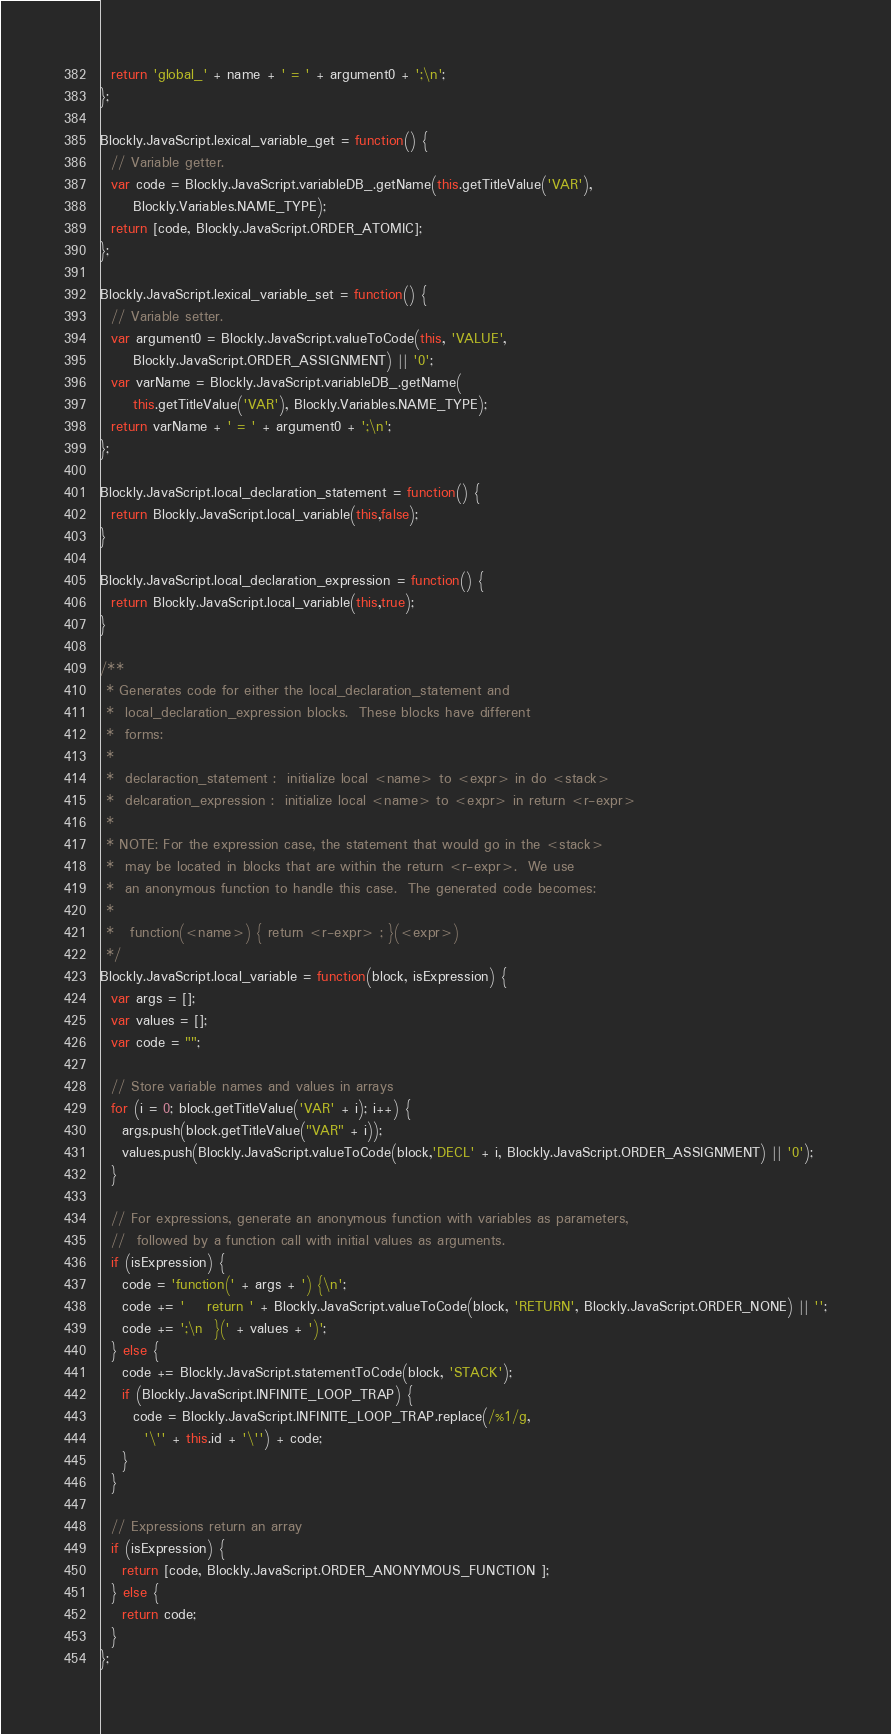<code> <loc_0><loc_0><loc_500><loc_500><_JavaScript_>  return 'global_' + name + ' = ' + argument0 + ';\n';
};

Blockly.JavaScript.lexical_variable_get = function() {
  // Variable getter.
  var code = Blockly.JavaScript.variableDB_.getName(this.getTitleValue('VAR'),
      Blockly.Variables.NAME_TYPE);
  return [code, Blockly.JavaScript.ORDER_ATOMIC];
};

Blockly.JavaScript.lexical_variable_set = function() {
  // Variable setter.
  var argument0 = Blockly.JavaScript.valueToCode(this, 'VALUE',
      Blockly.JavaScript.ORDER_ASSIGNMENT) || '0';
  var varName = Blockly.JavaScript.variableDB_.getName(
      this.getTitleValue('VAR'), Blockly.Variables.NAME_TYPE);
  return varName + ' = ' + argument0 + ';\n';
};

Blockly.JavaScript.local_declaration_statement = function() {
  return Blockly.JavaScript.local_variable(this,false);
}

Blockly.JavaScript.local_declaration_expression = function() {
  return Blockly.JavaScript.local_variable(this,true);
}

/**
 * Generates code for either the local_declaration_statement and
 *  local_declaration_expression blocks.  These blocks have different
 *  forms:
 *
 *  declaraction_statement :  initialize local <name> to <expr> in do <stack>
 *  delcaration_expression :  initialize local <name> to <expr> in return <r-expr>
 *
 * NOTE: For the expression case, the statement that would go in the <stack>
 *  may be located in blocks that are within the return <r-expr>.  We use
 *  an anonymous function to handle this case.  The generated code becomes:
 *
 *   function(<name>) { return <r-expr> ; }(<expr>)
 */
Blockly.JavaScript.local_variable = function(block, isExpression) {
  var args = [];
  var values = [];
  var code = "";

  // Store variable names and values in arrays
  for (i = 0; block.getTitleValue('VAR' + i); i++) {
    args.push(block.getTitleValue("VAR" + i));
    values.push(Blockly.JavaScript.valueToCode(block,'DECL' + i, Blockly.JavaScript.ORDER_ASSIGNMENT) || '0');
  }

  // For expressions, generate an anonymous function with variables as parameters,
  //  followed by a function call with initial values as arguments.
  if (isExpression) {
    code = 'function(' + args + ') {\n';
    code += '    return ' + Blockly.JavaScript.valueToCode(block, 'RETURN', Blockly.JavaScript.ORDER_NONE) || '';
    code += ';\n  }(' + values + ')';
  } else {
    code += Blockly.JavaScript.statementToCode(block, 'STACK');
    if (Blockly.JavaScript.INFINITE_LOOP_TRAP) {
      code = Blockly.JavaScript.INFINITE_LOOP_TRAP.replace(/%1/g,
        '\'' + this.id + '\'') + code;
    }
  }
  
  // Expressions return an array
  if (isExpression) {
    return [code, Blockly.JavaScript.ORDER_ANONYMOUS_FUNCTION ];
  } else {
    return code;
  }
};

</code> 